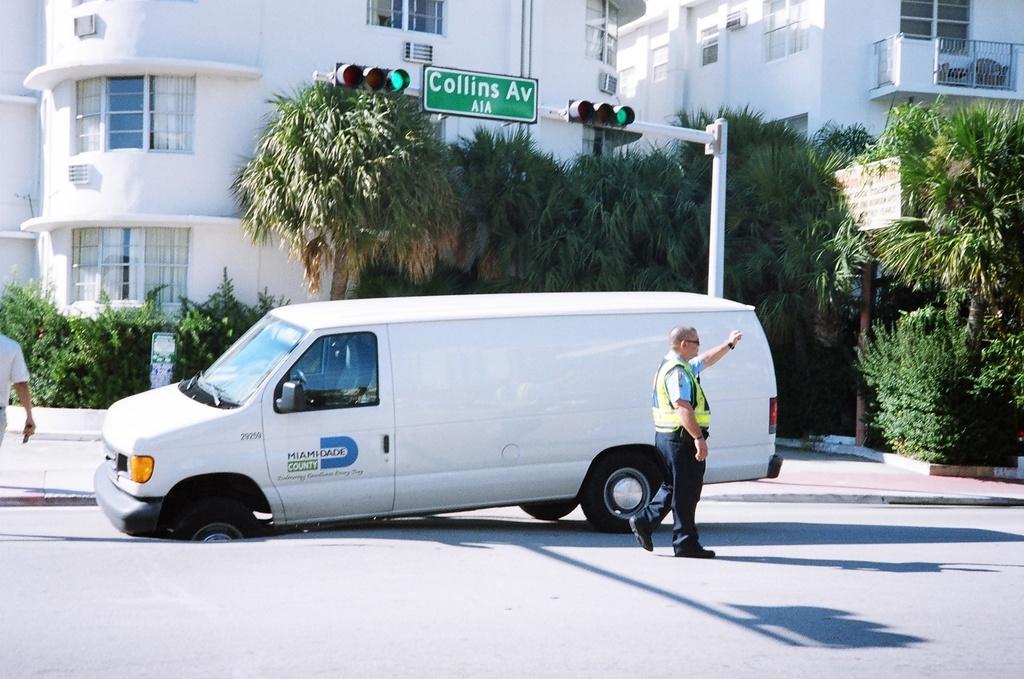What is the name of the street?
Your answer should be very brief. Collins av. What is the company name on the van?
Provide a short and direct response. Miami-dade county. 